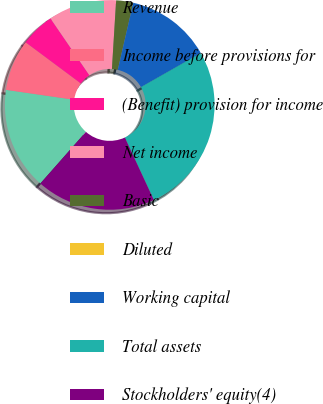Convert chart. <chart><loc_0><loc_0><loc_500><loc_500><pie_chart><fcel>Revenue<fcel>Income before provisions for<fcel>(Benefit) provision for income<fcel>Net income<fcel>Basic<fcel>Diluted<fcel>Working capital<fcel>Total assets<fcel>Stockholders' equity(4)<nl><fcel>15.79%<fcel>7.89%<fcel>5.26%<fcel>10.53%<fcel>2.63%<fcel>0.0%<fcel>13.16%<fcel>26.32%<fcel>18.42%<nl></chart> 